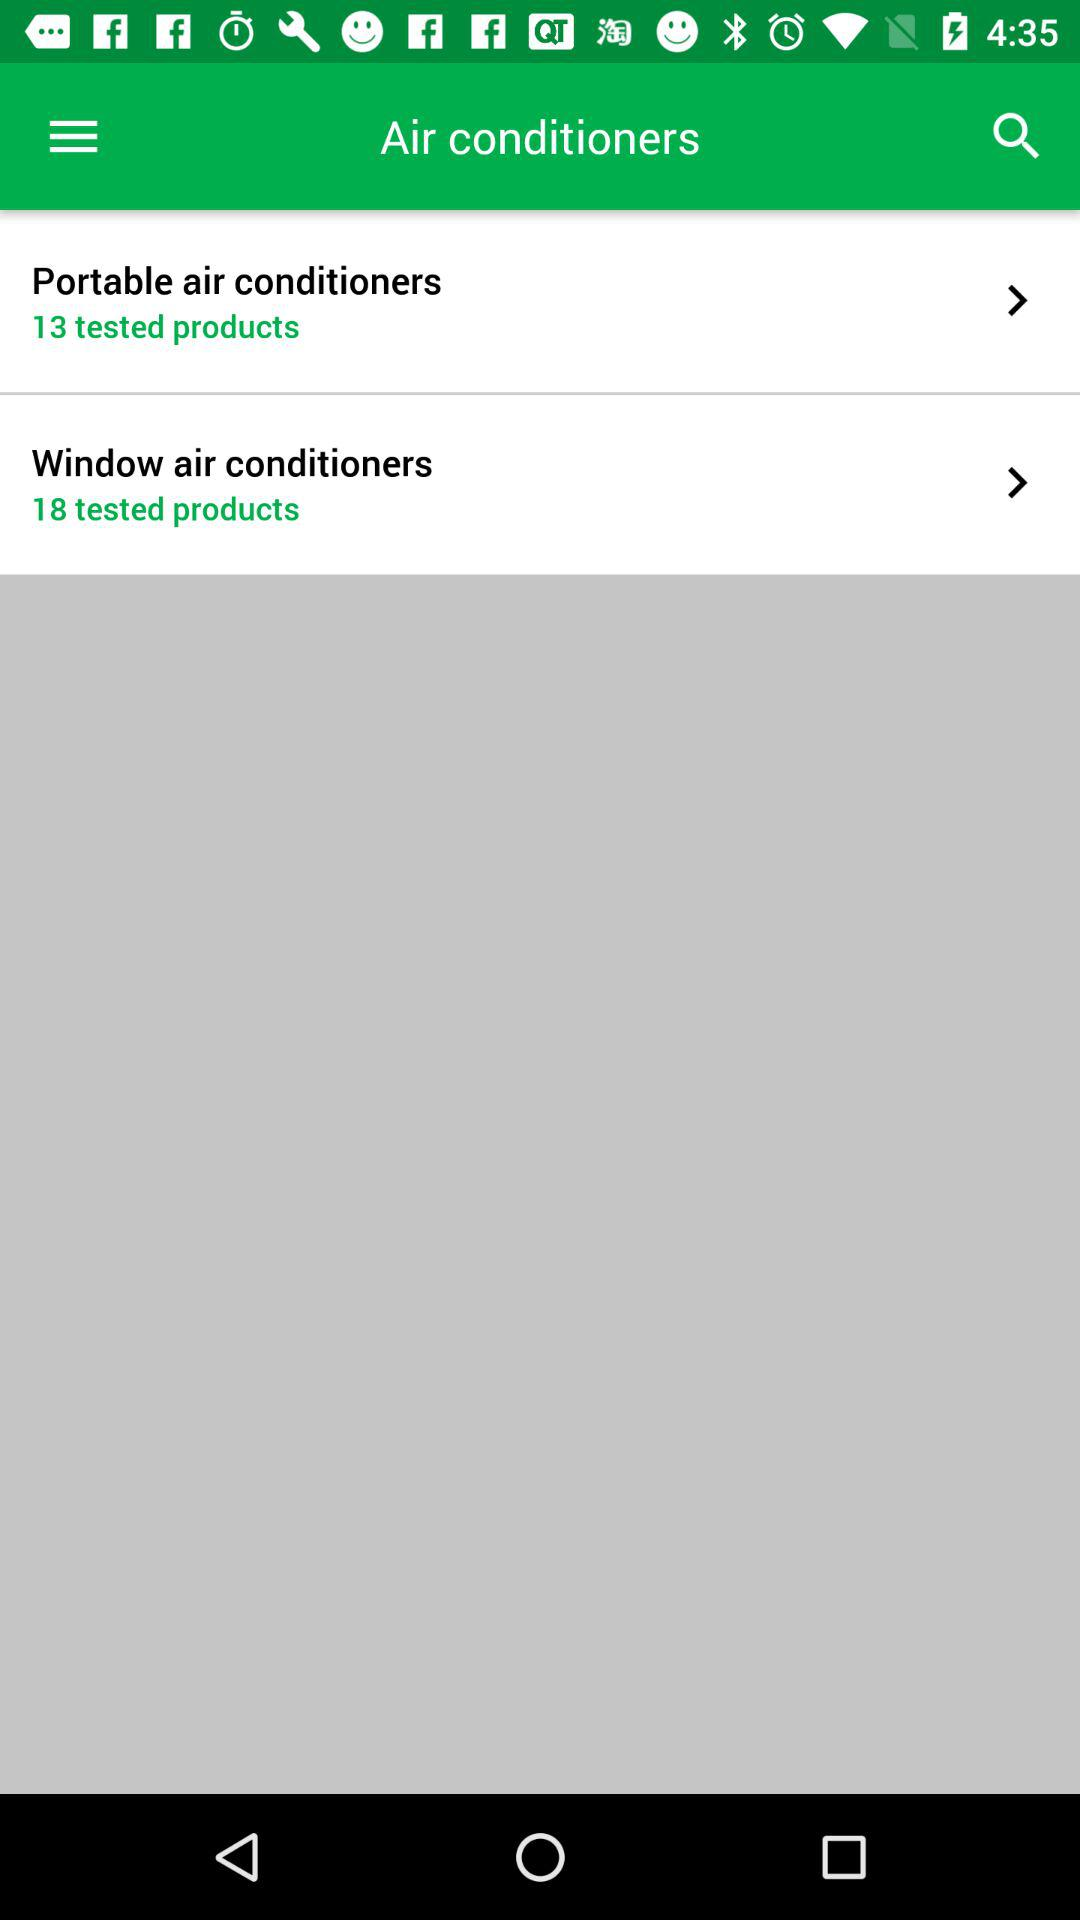How many products are tested for portable air conditioners? There are 13 products tested. 